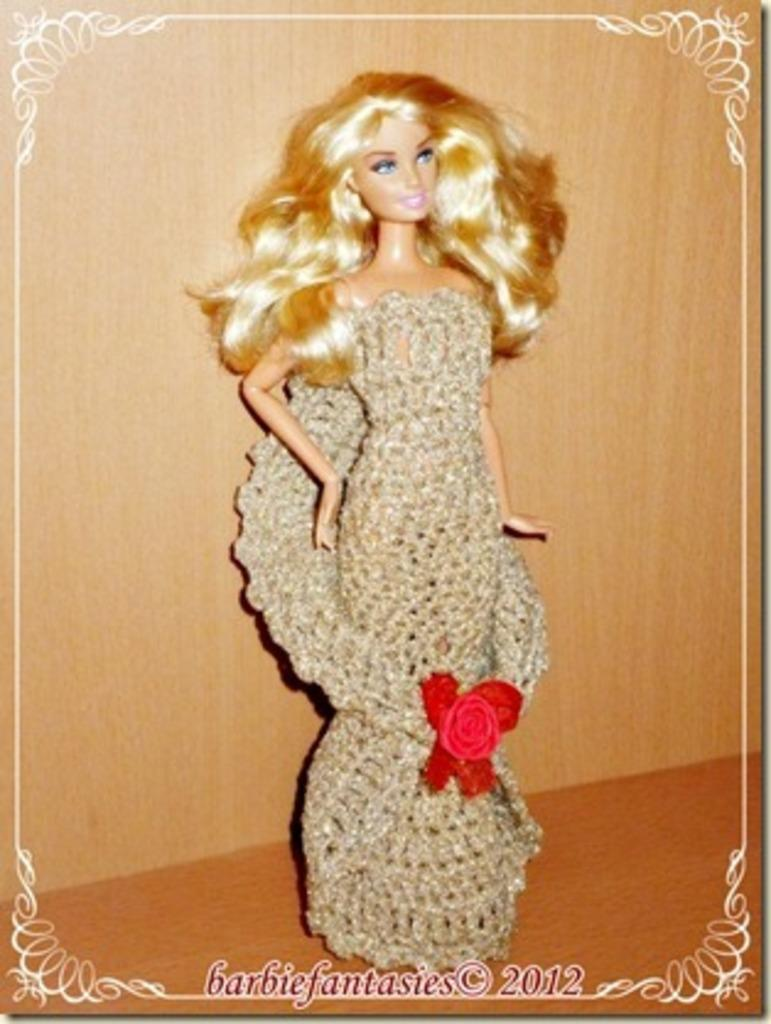What is the main subject in the center of the image? There is a toy in the center of the image. What can be seen in the background of the image? There is a wall in the background of the image? What is written or depicted at the bottom of the image? There is some text at the bottom of the image. What type of juice is being poured from the toy in the image? There is no juice or pouring action depicted in the image; it features a toy in the center and a wall in the background. 